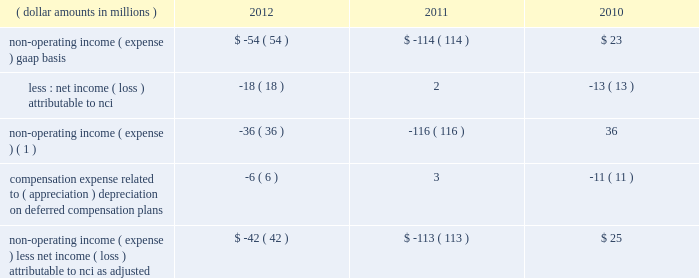The portion of compensation expense associated with certain long-term incentive plans ( 201cltip 201d ) funded or to be funded through share distributions to participants of blackrock stock held by pnc and a merrill lynch & co. , inc .
( 201cmerrill lynch 201d ) cash compensation contribution , has been excluded because it ultimately does not impact blackrock 2019s book value .
The expense related to the merrill lynch cash compensation contribution ceased at the end of third quarter 2011 .
As of first quarter 2012 , all of the merrill lynch contributions had been received .
Compensation expense associated with appreciation ( depreciation ) on investments related to certain blackrock deferred compensation plans has been excluded as returns on investments set aside for these plans , which substantially offset this expense , are reported in non-operating income ( expense ) .
Management believes operating income exclusive of these items is a useful measure in evaluating blackrock 2019s operating performance and helps enhance the comparability of this information for the reporting periods presented .
Operating margin , as adjusted : operating income used for measuring operating margin , as adjusted , is equal to operating income , as adjusted , excluding the impact of closed-end fund launch costs and commissions .
Management believes the exclusion of such costs and commissions is useful because these costs can fluctuate considerably and revenues associated with the expenditure of these costs will not fully impact the company 2019s results until future periods .
Operating margin , as adjusted , allows the company to compare performance from period-to-period by adjusting for items that may not recur , recur infrequently or may have an economic offset in non-operating income ( expense ) .
Examples of such adjustments include bgi transaction and integration costs , u.k .
Lease exit costs , contribution to stifs , restructuring charges , closed-end fund launch costs , commissions paid to certain employees as compensation and fluctuations in compensation expense based on mark-to-market movements in investments held to fund certain compensation plans .
The company also uses operating margin , as adjusted , to monitor corporate performance and efficiency and as a benchmark to compare its performance with other companies .
Management uses both the gaap and non- gaap financial measures in evaluating the financial performance of blackrock .
The non-gaap measure by itself may pose limitations because it does not include all of the company 2019s revenues and expenses .
Revenue used for operating margin , as adjusted , excludes distribution and servicing costs paid to related parties and other third parties .
Management believes the exclusion of such costs is useful because it creates consistency in the treatment for certain contracts for similar services , which due to the terms of the contracts , are accounted for under gaap on a net basis within investment advisory , administration fees and securities lending revenue .
Amortization of deferred sales commissions is excluded from revenue used for operating margin measurement , as adjusted , because such costs , over time , substantially offset distribution fee revenue earned by the company .
For each of these items , blackrock excludes from revenue used for operating margin , as adjusted , the costs related to each of these items as a proxy for such offsetting revenues .
( b ) non-operating income ( expense ) , less net income ( loss ) attributable to non-controlling interests , as adjusted : non-operating income ( expense ) , less net income ( loss ) attributable to nci , as adjusted , is presented below .
The compensation expense offset is recorded in operating income .
This compensation expense has been included in non-operating income ( expense ) , less net income ( loss ) attributable to nci , as adjusted , to offset returns on investments set aside for these plans , which are reported in non-operating income ( expense ) , gaap basis .
( dollar amounts in millions ) 2012 2011 2010 non-operating income ( expense ) , gaap basis .
$ ( 54 ) $ ( 114 ) $ 23 less : net income ( loss ) attributable to nci .
( 18 ) 2 ( 13 ) non-operating income ( expense ) ( 1 ) .
( 36 ) ( 116 ) 36 compensation expense related to ( appreciation ) depreciation on deferred compensation plans .
( 6 ) 3 ( 11 ) non-operating income ( expense ) , less net income ( loss ) attributable to nci , as adjusted .
$ ( 42 ) $ ( 113 ) $ 25 ( 1 ) net of net income ( loss ) attributable to nci .
Management believes non-operating income ( expense ) , less net income ( loss ) attributable to nci , as adjusted , provides comparability of this information among reporting periods and is an effective measure for reviewing blackrock 2019s non-operating contribution to its results .
As compensation expense associated with ( appreciation ) depreciation on investments related to certain deferred compensation plans , which is included in operating income , substantially offsets the gain ( loss ) on the investments set aside for these plans , management .
The portion of compensation expense associated with certain long-term incentive plans ( 201cltip 201d ) funded or to be funded through share distributions to participants of blackrock stock held by pnc and a merrill lynch & co. , inc .
( 201cmerrill lynch 201d ) cash compensation contribution , has been excluded because it ultimately does not impact blackrock 2019s book value .
The expense related to the merrill lynch cash compensation contribution ceased at the end of third quarter 2011 .
As of first quarter 2012 , all of the merrill lynch contributions had been received .
Compensation expense associated with appreciation ( depreciation ) on investments related to certain blackrock deferred compensation plans has been excluded as returns on investments set aside for these plans , which substantially offset this expense , are reported in non-operating income ( expense ) .
Management believes operating income exclusive of these items is a useful measure in evaluating blackrock 2019s operating performance and helps enhance the comparability of this information for the reporting periods presented .
Operating margin , as adjusted : operating income used for measuring operating margin , as adjusted , is equal to operating income , as adjusted , excluding the impact of closed-end fund launch costs and commissions .
Management believes the exclusion of such costs and commissions is useful because these costs can fluctuate considerably and revenues associated with the expenditure of these costs will not fully impact the company 2019s results until future periods .
Operating margin , as adjusted , allows the company to compare performance from period-to-period by adjusting for items that may not recur , recur infrequently or may have an economic offset in non-operating income ( expense ) .
Examples of such adjustments include bgi transaction and integration costs , u.k .
Lease exit costs , contribution to stifs , restructuring charges , closed-end fund launch costs , commissions paid to certain employees as compensation and fluctuations in compensation expense based on mark-to-market movements in investments held to fund certain compensation plans .
The company also uses operating margin , as adjusted , to monitor corporate performance and efficiency and as a benchmark to compare its performance with other companies .
Management uses both the gaap and non- gaap financial measures in evaluating the financial performance of blackrock .
The non-gaap measure by itself may pose limitations because it does not include all of the company 2019s revenues and expenses .
Revenue used for operating margin , as adjusted , excludes distribution and servicing costs paid to related parties and other third parties .
Management believes the exclusion of such costs is useful because it creates consistency in the treatment for certain contracts for similar services , which due to the terms of the contracts , are accounted for under gaap on a net basis within investment advisory , administration fees and securities lending revenue .
Amortization of deferred sales commissions is excluded from revenue used for operating margin measurement , as adjusted , because such costs , over time , substantially offset distribution fee revenue earned by the company .
For each of these items , blackrock excludes from revenue used for operating margin , as adjusted , the costs related to each of these items as a proxy for such offsetting revenues .
( b ) non-operating income ( expense ) , less net income ( loss ) attributable to non-controlling interests , as adjusted : non-operating income ( expense ) , less net income ( loss ) attributable to nci , as adjusted , is presented below .
The compensation expense offset is recorded in operating income .
This compensation expense has been included in non-operating income ( expense ) , less net income ( loss ) attributable to nci , as adjusted , to offset returns on investments set aside for these plans , which are reported in non-operating income ( expense ) , gaap basis .
( dollar amounts in millions ) 2012 2011 2010 non-operating income ( expense ) , gaap basis .
$ ( 54 ) $ ( 114 ) $ 23 less : net income ( loss ) attributable to nci .
( 18 ) 2 ( 13 ) non-operating income ( expense ) ( 1 ) .
( 36 ) ( 116 ) 36 compensation expense related to ( appreciation ) depreciation on deferred compensation plans .
( 6 ) 3 ( 11 ) non-operating income ( expense ) , less net income ( loss ) attributable to nci , as adjusted .
$ ( 42 ) $ ( 113 ) $ 25 ( 1 ) net of net income ( loss ) attributable to nci .
Management believes non-operating income ( expense ) , less net income ( loss ) attributable to nci , as adjusted , provides comparability of this information among reporting periods and is an effective measure for reviewing blackrock 2019s non-operating contribution to its results .
As compensation expense associated with ( appreciation ) depreciation on investments related to certain deferred compensation plans , which is included in operating income , substantially offsets the gain ( loss ) on the investments set aside for these plans , management .
What losses are attributable to nci between 2010 and 2012 ? in millions $ .? 
Computations: ((18 + 13) - 2)
Answer: 29.0. 